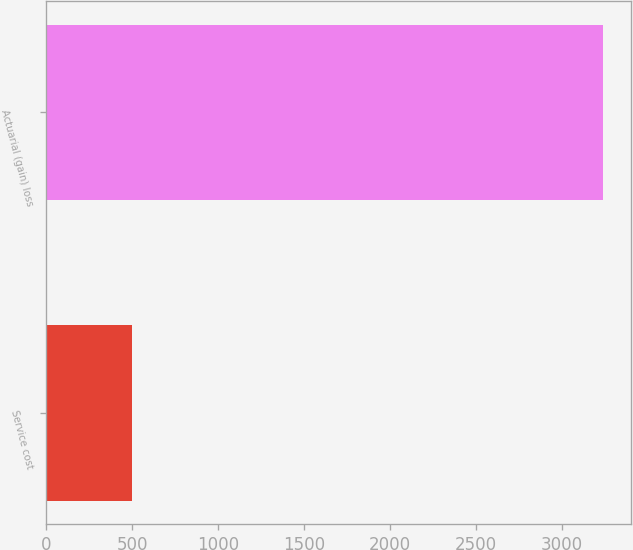Convert chart to OTSL. <chart><loc_0><loc_0><loc_500><loc_500><bar_chart><fcel>Service cost<fcel>Actuarial (gain) loss<nl><fcel>499<fcel>3242<nl></chart> 